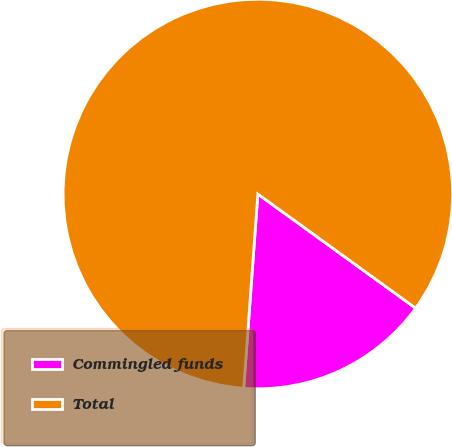<chart> <loc_0><loc_0><loc_500><loc_500><pie_chart><fcel>Commingled funds<fcel>Total<nl><fcel>16.19%<fcel>83.81%<nl></chart> 